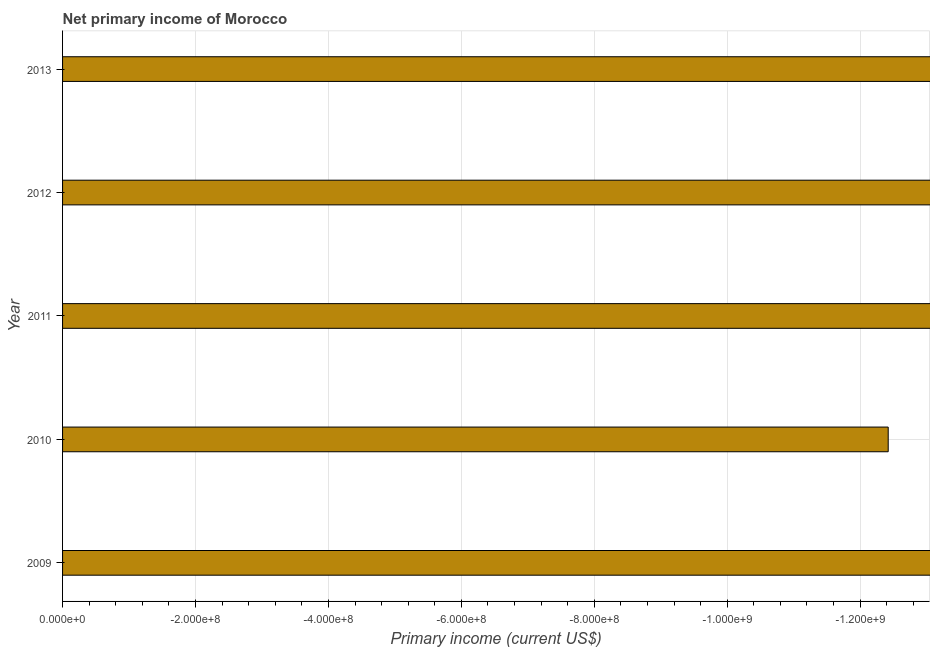What is the title of the graph?
Ensure brevity in your answer.  Net primary income of Morocco. What is the label or title of the X-axis?
Keep it short and to the point. Primary income (current US$). What is the label or title of the Y-axis?
Make the answer very short. Year. What is the median amount of primary income?
Your response must be concise. 0. In how many years, is the amount of primary income greater than the average amount of primary income taken over all years?
Provide a succinct answer. 0. How many years are there in the graph?
Your response must be concise. 5. Are the values on the major ticks of X-axis written in scientific E-notation?
Make the answer very short. Yes. What is the Primary income (current US$) of 2011?
Your answer should be compact. 0. What is the Primary income (current US$) in 2012?
Your answer should be compact. 0. What is the Primary income (current US$) of 2013?
Offer a terse response. 0. 